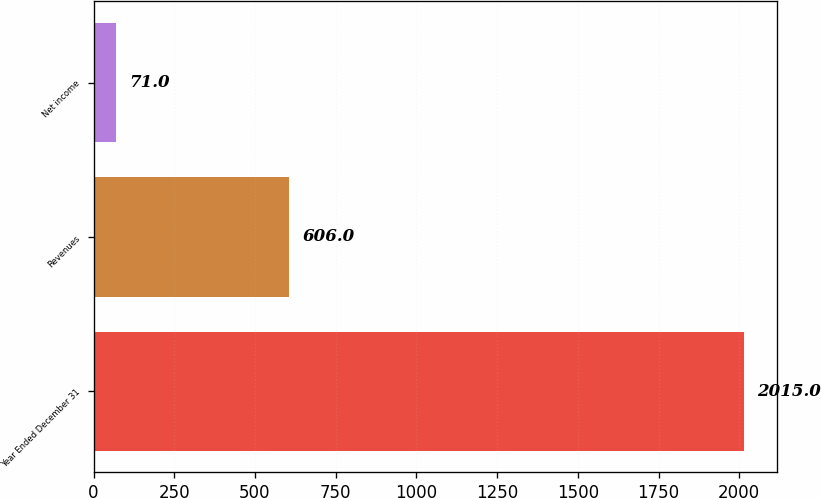Convert chart to OTSL. <chart><loc_0><loc_0><loc_500><loc_500><bar_chart><fcel>Year Ended December 31<fcel>Revenues<fcel>Net income<nl><fcel>2015<fcel>606<fcel>71<nl></chart> 